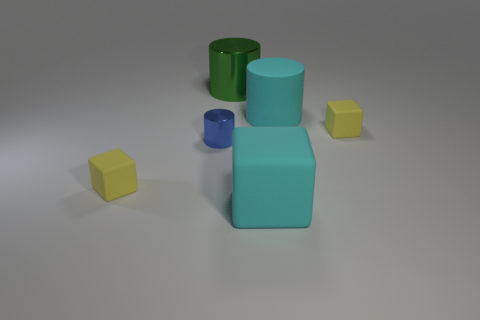Does the big rubber block have the same color as the rubber cylinder?
Keep it short and to the point. Yes. There is a matte object that is both to the left of the large cyan rubber cylinder and behind the big cyan block; what shape is it?
Ensure brevity in your answer.  Cube. Does the rubber cylinder have the same color as the large matte object that is in front of the small cylinder?
Your answer should be compact. Yes. What color is the tiny thing on the left side of the blue metallic cylinder?
Make the answer very short. Yellow. How many matte objects are the same color as the big block?
Provide a short and direct response. 1. What number of large objects are both behind the large cyan rubber cube and to the left of the cyan cylinder?
Offer a terse response. 1. What is the shape of the cyan matte object that is the same size as the cyan cylinder?
Your response must be concise. Cube. What size is the blue metallic object?
Ensure brevity in your answer.  Small. There is a cylinder that is in front of the yellow cube behind the metal cylinder to the left of the large green metal cylinder; what is its material?
Your response must be concise. Metal. What color is the big cylinder that is the same material as the cyan cube?
Offer a terse response. Cyan. 